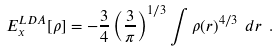<formula> <loc_0><loc_0><loc_500><loc_500>E _ { x } ^ { L D A } [ \rho ] = - { \frac { 3 } { 4 } } \left ( { \frac { 3 } { \pi } } \right ) ^ { 1 / 3 } \int \rho ( r ) ^ { 4 / 3 } \ d r \ .</formula> 